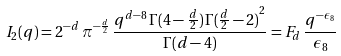<formula> <loc_0><loc_0><loc_500><loc_500>I _ { 2 } ( q ) = { 2 ^ { - d } } \, { { \pi } ^ { - { \frac { d } { 2 } } } } \, { \frac { { q ^ { d - 8 } } \, { \Gamma } ( 4 - { \frac { d } { 2 } } ) \, { { { \Gamma } ( { \frac { d } { 2 } } - 2 ) } ^ { 2 } } } { { \Gamma } ( d - 4 ) } } = F _ { d } \, \frac { q ^ { - \epsilon _ { 8 } } } { \epsilon _ { 8 } }</formula> 